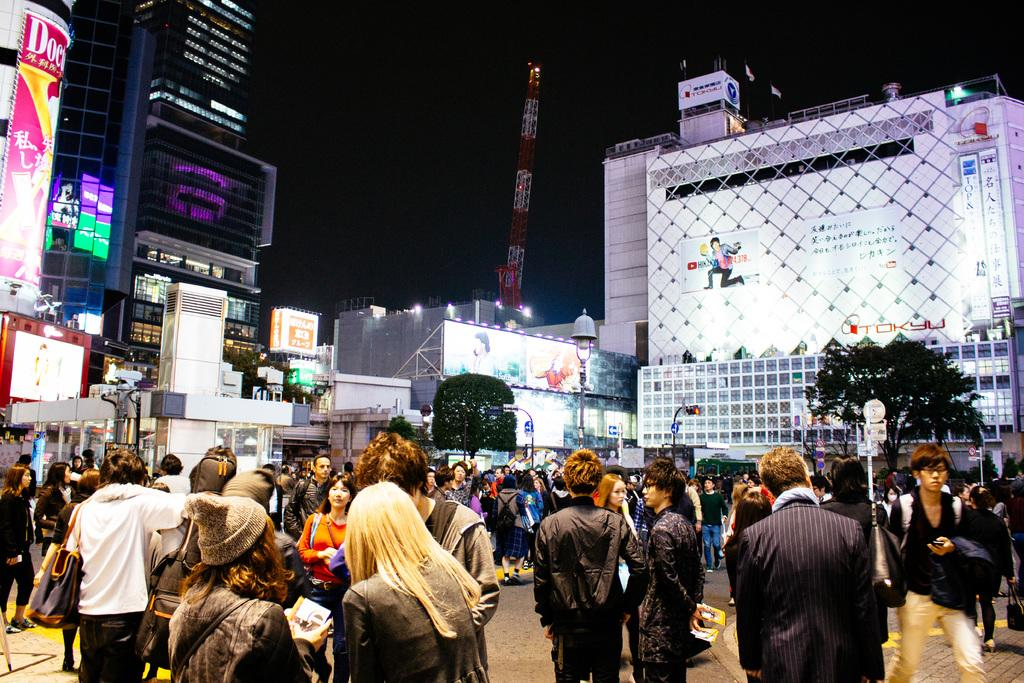What type of structures are present in the image? There are sky scrapers, buildings, and a tower in the image. What additional features can be seen in the image? There are advertisement boards, trees, street poles, street lights, and stores in the image. Are there any signs of human presence? Yes, there are people standing on the road in the image. How many crates are stacked on top of each other in the image? There are no crates present in the image. What is the amount of water in the tub visible in the image? There is no tub or water present in the image. 